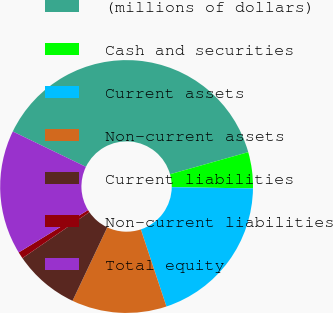<chart> <loc_0><loc_0><loc_500><loc_500><pie_chart><fcel>(millions of dollars)<fcel>Cash and securities<fcel>Current assets<fcel>Non-current assets<fcel>Current liabilities<fcel>Non-current liabilities<fcel>Total equity<nl><fcel>38.45%<fcel>4.62%<fcel>19.66%<fcel>12.14%<fcel>8.38%<fcel>0.86%<fcel>15.9%<nl></chart> 